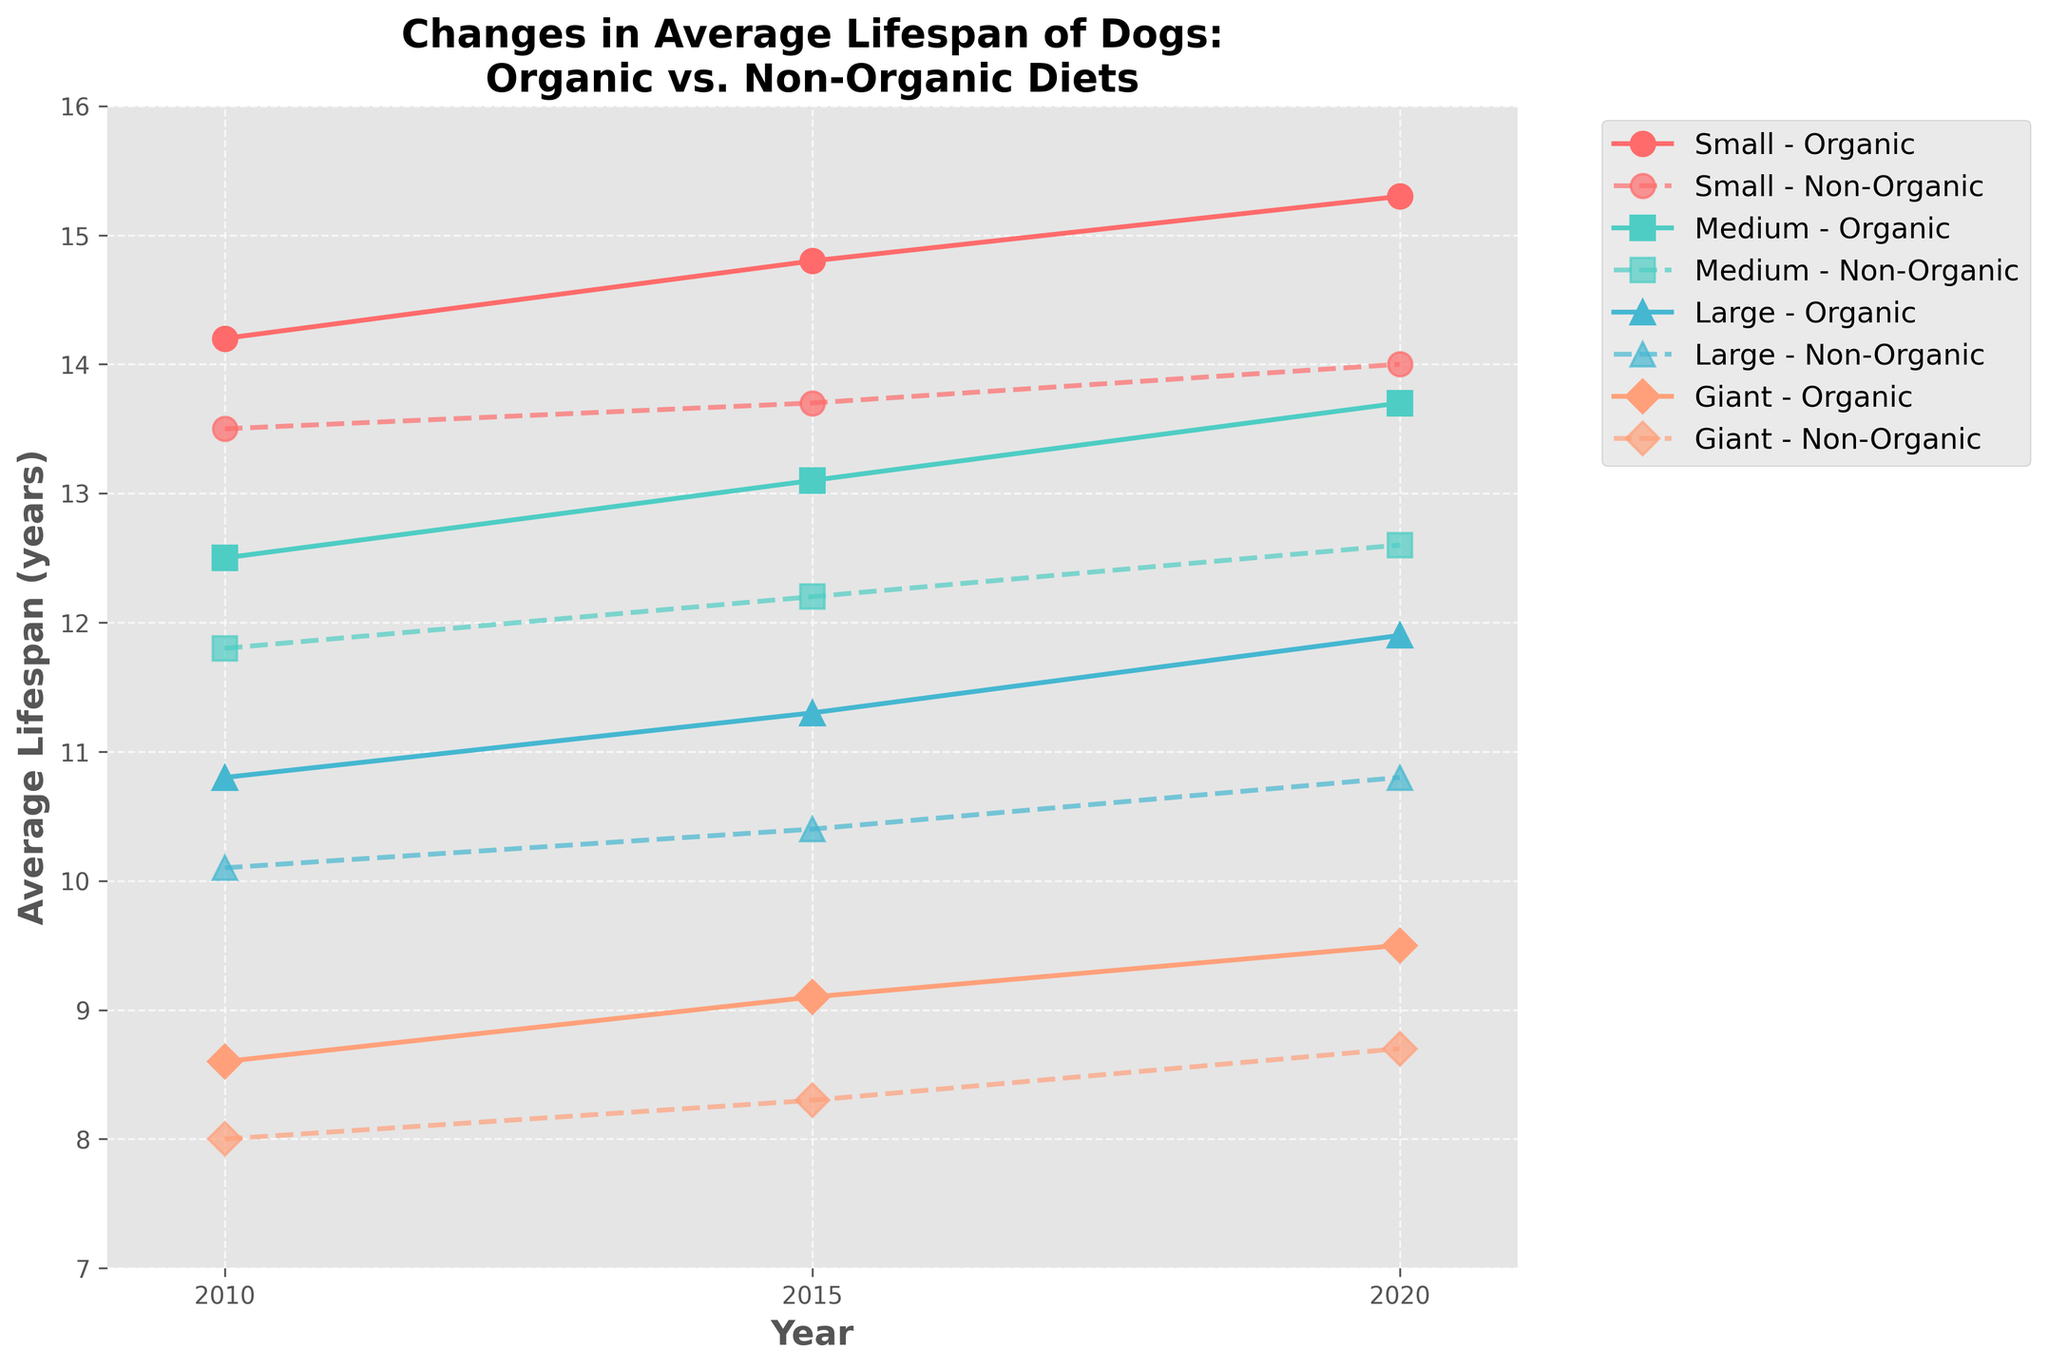How did the lifespan of dogs on an organic diet change for medium breeds from 2010 to 2020? The lifespan for medium breeds on an organic diet increased from 12.5 years in 2010 to 13.7 years in 2020.
Answer: 1.2 years Which breed size had the largest difference in average lifespan between organic and non-organic diets in 2020? For each breed size in 2020, subtract the average lifespan for non-organic diets from the organic diet:
Small: 15.3 - 14.0 = 1.3 years
Medium: 13.7 - 12.6 = 1.1 years
Large: 11.9 - 10.8 = 1.1 years
Giant: 9.5 - 8.7 = 0.8 years
The Small breed size had the largest difference of 1.3 years.
Answer: Small breed Has the average lifespan gap between organic and non-organic diets increased or decreased for Giant breeds from 2010 to 2020? In 2010, the gap was 8.6 - 8.0 = 0.6 years. In 2020, the gap was 9.5 - 8.7 = 0.8 years. The gap has increased over the period.
Answer: Increased By how many years does the average lifespan of dogs on an organic diet surpass those on a non-organic diet in 2015 for large breeds? For large breeds in 2015, the average lifespan for organic diets is 11.3 years and for non-organic diets is 10.4 years. The difference is:
11.3 - 10.4 = 0.9 years
Answer: 0.9 years Looking at the visual differences, which breed size shows the least improvement in average lifespan on an organic diet from 2010 to 2020? For each breed size, subtract the 2010 value from the 2020 value:
Small: 15.3 - 14.2 = 1.1 years
Medium: 13.7 - 12.5 = 1.2 years
Large: 11.9 - 10.8 = 1.1 years
Giant: 9.5 - 8.6 = 0.9 years
The Giant breed shows the least improvement of 0.9 years.
Answer: Giant breed Which breed size had the highest average lifespan on an organic diet in 2020, and what was it? The average lifespan on an organic diet in 2020 for each breed size is:
Small: 15.3 years
Medium: 13.7 years
Large: 11.9 years
Giant: 9.5 years
The Small breed size had the highest lifespan with 15.3 years.
Answer: Small breed, 15.3 years What is the average lifespan difference between organic and non-organic diets for all breed sizes in 2020 on average? Difference for each breed size in 2020:
Small: 15.3 - 14.0 = 1.3 years
Medium: 13.7 - 12.6 = 1.1 years
Large: 11.9 - 10.8 = 1.1 years
Giant: 9.5 - 8.7 = 0.8 years
Average difference = (1.3 + 1.1 + 1.1 + 0.8) / 4 = 1.075 years
Answer: 1.075 years How did the average lifespan of dogs on a non-organic diet change for small breeds from 2015 to 2020? The average lifespan for small breeds on a non-organic diet increased from 13.7 years in 2015 to 14.0 years in 2020, which is a 0.3-year increase.
Answer: 0.3 years Is there a year where the medium breed size on a non-organic diet has a better lifespan than the large breed size on an organic diet? In each year, compare the lifespan of the medium breed size on a non-organic diet with the large breed size on an organic diet:
2010: Medium (11.8) < Large (10.8) => No
2015: Medium (12.2) > Large (11.3) => Yes
2020: Medium (12.6) > Large (11.9) => Yes
So, in 2015 and 2020, the non-organic medium breed had a better lifespan than the organic large breed.
Answer: Yes, 2015 and 2020 Which breed size shows the greatest improvement in average lifespan on an organic diet from 2010 to 2020? For each breed size, subtract the 2010 value from the 2020 value:
Small: 15.3 - 14.2 = 1.1 years
Medium: 13.7 - 12.5 = 1.2 years
Large: 11.9 - 10.8 = 1.1 years
Giant: 9.5 - 8.6 = 0.9 years
The Medium breed shows the greatest improvement of 1.2 years.
Answer: Medium breed 